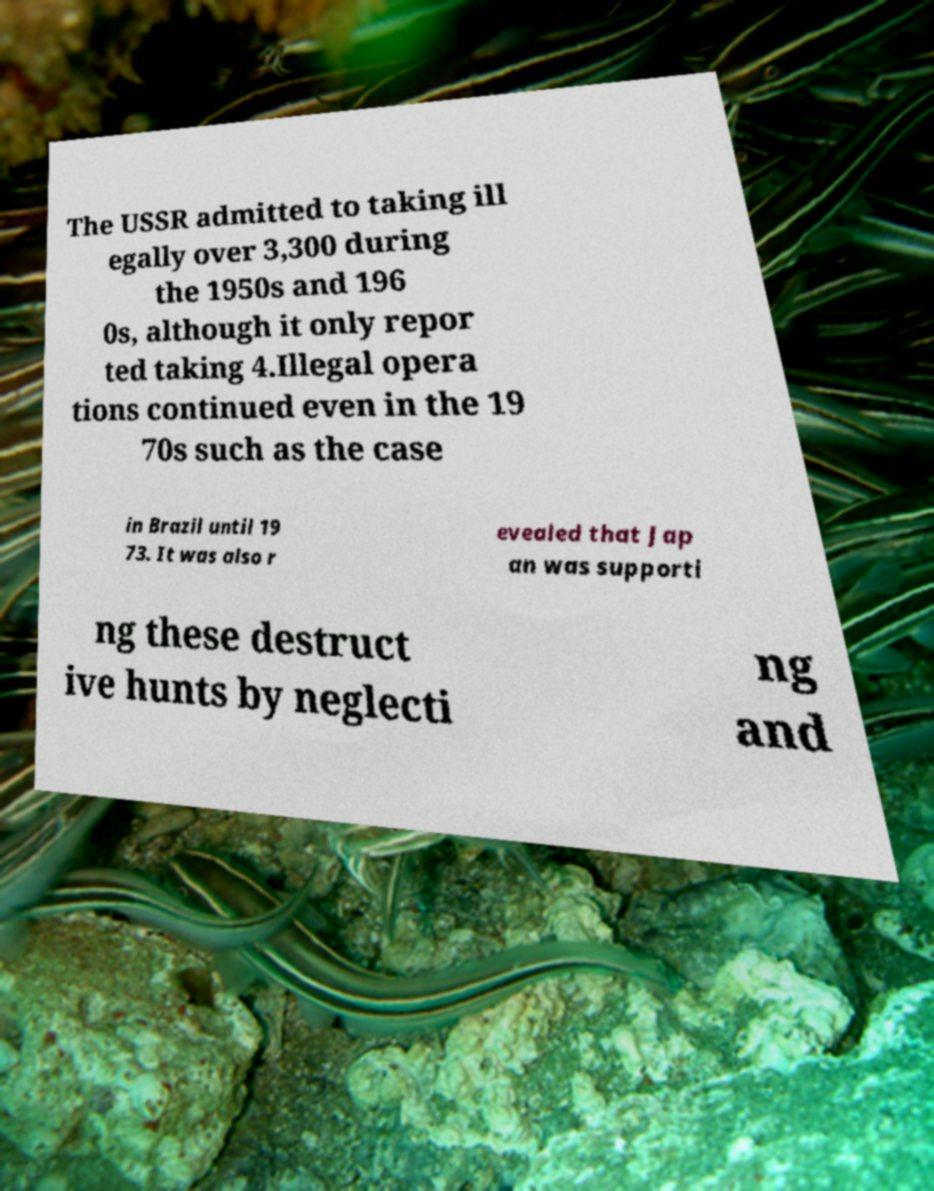Could you extract and type out the text from this image? The USSR admitted to taking ill egally over 3,300 during the 1950s and 196 0s, although it only repor ted taking 4.Illegal opera tions continued even in the 19 70s such as the case in Brazil until 19 73. It was also r evealed that Jap an was supporti ng these destruct ive hunts by neglecti ng and 